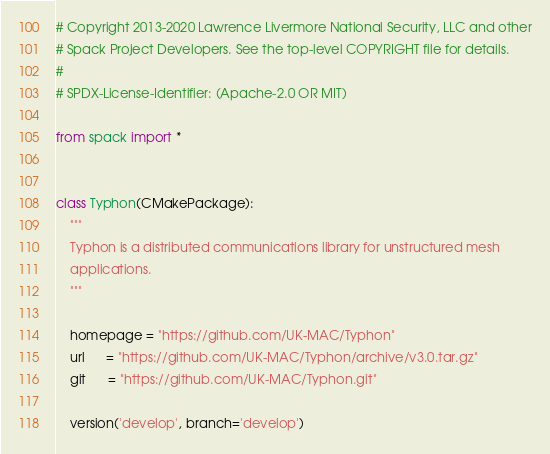<code> <loc_0><loc_0><loc_500><loc_500><_Python_># Copyright 2013-2020 Lawrence Livermore National Security, LLC and other
# Spack Project Developers. See the top-level COPYRIGHT file for details.
#
# SPDX-License-Identifier: (Apache-2.0 OR MIT)

from spack import *


class Typhon(CMakePackage):
    """
    Typhon is a distributed communications library for unstructured mesh
    applications.
    """

    homepage = "https://github.com/UK-MAC/Typhon"
    url      = "https://github.com/UK-MAC/Typhon/archive/v3.0.tar.gz"
    git      = "https://github.com/UK-MAC/Typhon.git"

    version('develop', branch='develop')
</code> 